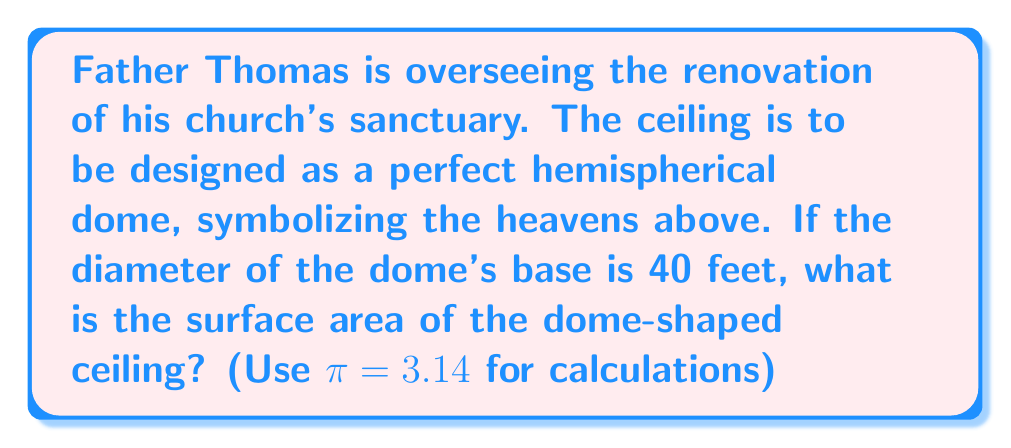Solve this math problem. To solve this problem, let's approach it step-by-step:

1) First, recall that the surface area of a hemisphere is given by the formula:

   $$A = 2\pi r^2$$

   Where $r$ is the radius of the hemisphere.

2) We're given the diameter of the dome's base, which is 40 feet. The radius is half of this:

   $$r = \frac{40}{2} = 20\text{ feet}$$

3) Now we can substitute this into our formula:

   $$A = 2\pi (20)^2$$

4) Simplify the squared term:

   $$A = 2\pi (400)$$

5) Multiply:

   $$A = 800\pi$$

6) Now, we can use the given value of $\pi = 3.14$:

   $$A = 800 * 3.14 = 2,512\text{ square feet}$$

This calculation gives us the surface area of the dome-shaped ceiling, representing the vastness of God's creation above the congregation.

[asy]
import geometry;

size(200);
pair O = (0,0);
real r = 5;
draw(Circle(O,r),blue);
draw((-r,0)--(r,0),blue);
draw(O--(0,r),blue);
label("r",(-r/2,r/2),NE);
label("40 ft",(-r,0),S);
[/asy]
Answer: The surface area of the dome-shaped sanctuary ceiling is approximately 2,512 square feet. 